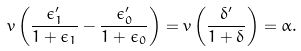<formula> <loc_0><loc_0><loc_500><loc_500>v \left ( \frac { \epsilon _ { 1 } ^ { \prime } } { 1 + \epsilon _ { 1 } } - \frac { \epsilon _ { 0 } ^ { \prime } } { 1 + \epsilon _ { 0 } } \right ) = v \left ( \frac { \delta ^ { \prime } } { 1 + \delta } \right ) = \alpha .</formula> 